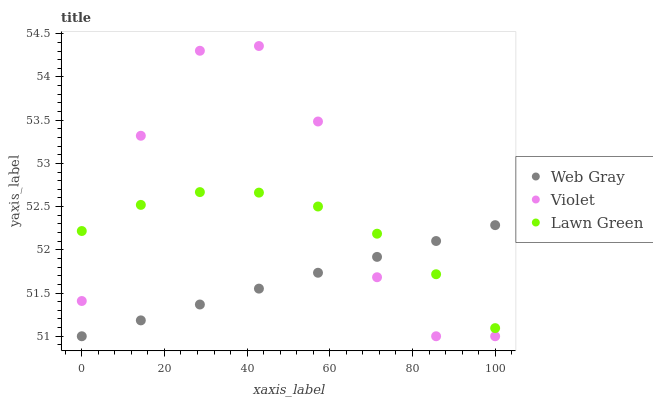Does Web Gray have the minimum area under the curve?
Answer yes or no. Yes. Does Violet have the maximum area under the curve?
Answer yes or no. Yes. Does Violet have the minimum area under the curve?
Answer yes or no. No. Does Web Gray have the maximum area under the curve?
Answer yes or no. No. Is Web Gray the smoothest?
Answer yes or no. Yes. Is Violet the roughest?
Answer yes or no. Yes. Is Violet the smoothest?
Answer yes or no. No. Is Web Gray the roughest?
Answer yes or no. No. Does Web Gray have the lowest value?
Answer yes or no. Yes. Does Violet have the highest value?
Answer yes or no. Yes. Does Web Gray have the highest value?
Answer yes or no. No. Does Lawn Green intersect Web Gray?
Answer yes or no. Yes. Is Lawn Green less than Web Gray?
Answer yes or no. No. Is Lawn Green greater than Web Gray?
Answer yes or no. No. 